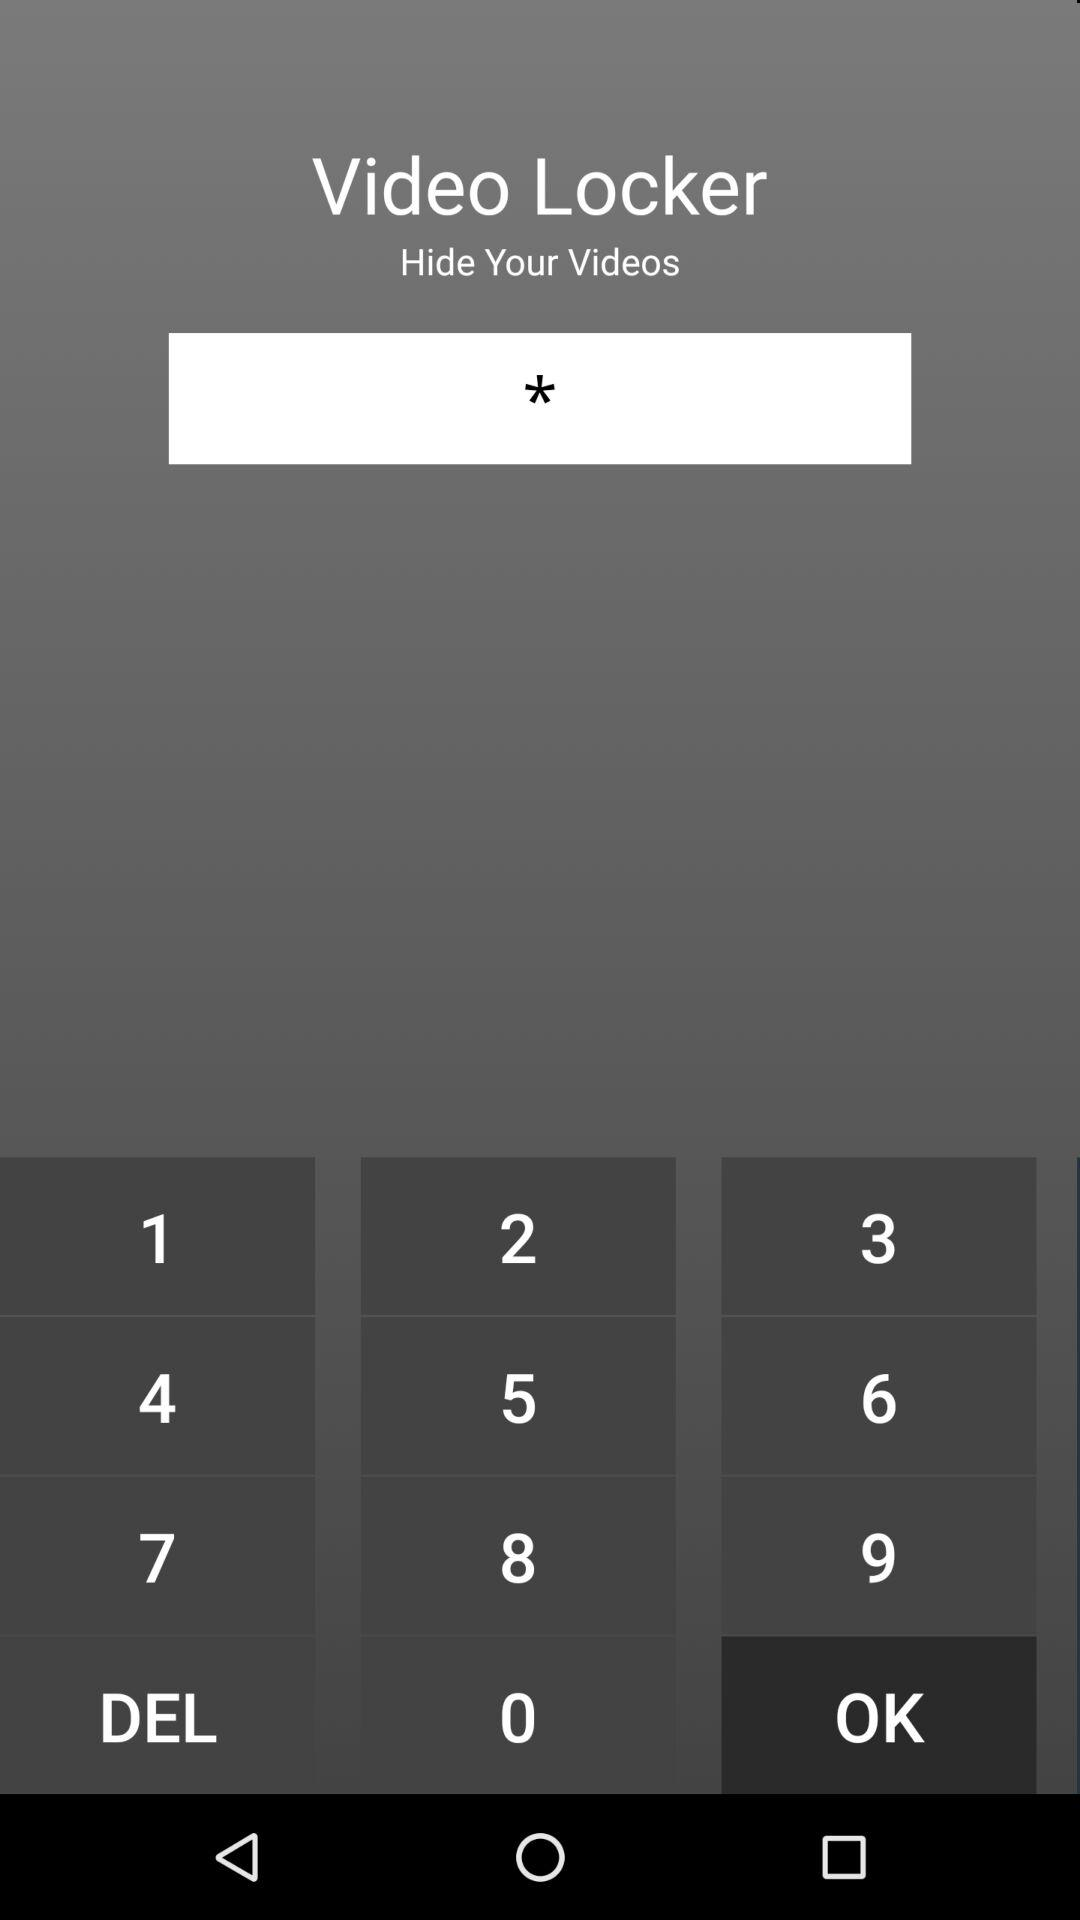What is the application name? The application name is "Video Locker". 